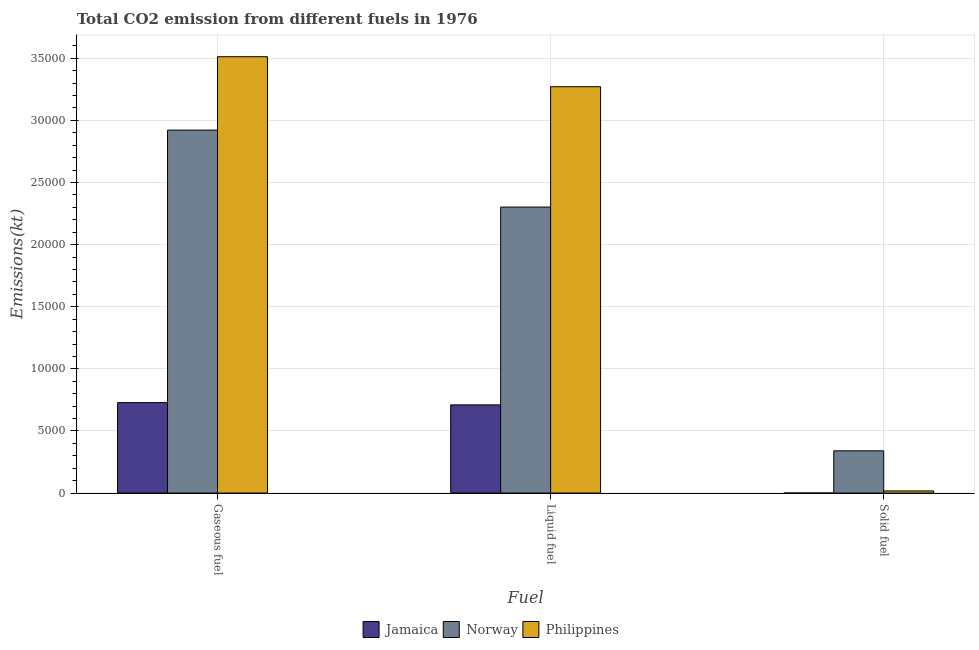How many different coloured bars are there?
Offer a very short reply. 3. How many bars are there on the 3rd tick from the left?
Give a very brief answer. 3. What is the label of the 3rd group of bars from the left?
Give a very brief answer. Solid fuel. What is the amount of co2 emissions from solid fuel in Norway?
Give a very brief answer. 3402.98. Across all countries, what is the maximum amount of co2 emissions from liquid fuel?
Your answer should be compact. 3.27e+04. Across all countries, what is the minimum amount of co2 emissions from solid fuel?
Give a very brief answer. 3.67. In which country was the amount of co2 emissions from liquid fuel maximum?
Make the answer very short. Philippines. In which country was the amount of co2 emissions from gaseous fuel minimum?
Make the answer very short. Jamaica. What is the total amount of co2 emissions from liquid fuel in the graph?
Your answer should be compact. 6.28e+04. What is the difference between the amount of co2 emissions from gaseous fuel in Philippines and that in Jamaica?
Keep it short and to the point. 2.78e+04. What is the difference between the amount of co2 emissions from solid fuel in Norway and the amount of co2 emissions from gaseous fuel in Jamaica?
Make the answer very short. -3879.69. What is the average amount of co2 emissions from liquid fuel per country?
Provide a short and direct response. 2.09e+04. What is the difference between the amount of co2 emissions from solid fuel and amount of co2 emissions from gaseous fuel in Philippines?
Your response must be concise. -3.50e+04. In how many countries, is the amount of co2 emissions from liquid fuel greater than 16000 kt?
Provide a short and direct response. 2. What is the ratio of the amount of co2 emissions from gaseous fuel in Jamaica to that in Norway?
Provide a short and direct response. 0.25. Is the amount of co2 emissions from solid fuel in Philippines less than that in Norway?
Provide a short and direct response. Yes. What is the difference between the highest and the second highest amount of co2 emissions from liquid fuel?
Your response must be concise. 9688.21. What is the difference between the highest and the lowest amount of co2 emissions from solid fuel?
Offer a terse response. 3399.31. Is the sum of the amount of co2 emissions from liquid fuel in Norway and Jamaica greater than the maximum amount of co2 emissions from solid fuel across all countries?
Your answer should be compact. Yes. What does the 3rd bar from the left in Liquid fuel represents?
Give a very brief answer. Philippines. What does the 3rd bar from the right in Liquid fuel represents?
Make the answer very short. Jamaica. Are all the bars in the graph horizontal?
Provide a succinct answer. No. How many countries are there in the graph?
Keep it short and to the point. 3. Does the graph contain any zero values?
Your answer should be compact. No. Where does the legend appear in the graph?
Make the answer very short. Bottom center. What is the title of the graph?
Offer a terse response. Total CO2 emission from different fuels in 1976. Does "Upper middle income" appear as one of the legend labels in the graph?
Provide a short and direct response. No. What is the label or title of the X-axis?
Provide a succinct answer. Fuel. What is the label or title of the Y-axis?
Ensure brevity in your answer.  Emissions(kt). What is the Emissions(kt) of Jamaica in Gaseous fuel?
Provide a short and direct response. 7282.66. What is the Emissions(kt) of Norway in Gaseous fuel?
Provide a succinct answer. 2.92e+04. What is the Emissions(kt) in Philippines in Gaseous fuel?
Offer a terse response. 3.51e+04. What is the Emissions(kt) in Jamaica in Liquid fuel?
Your response must be concise. 7099.31. What is the Emissions(kt) of Norway in Liquid fuel?
Your answer should be very brief. 2.30e+04. What is the Emissions(kt) of Philippines in Liquid fuel?
Your answer should be compact. 3.27e+04. What is the Emissions(kt) of Jamaica in Solid fuel?
Make the answer very short. 3.67. What is the Emissions(kt) of Norway in Solid fuel?
Your answer should be compact. 3402.98. What is the Emissions(kt) of Philippines in Solid fuel?
Provide a succinct answer. 172.35. Across all Fuel, what is the maximum Emissions(kt) of Jamaica?
Offer a terse response. 7282.66. Across all Fuel, what is the maximum Emissions(kt) in Norway?
Your answer should be compact. 2.92e+04. Across all Fuel, what is the maximum Emissions(kt) of Philippines?
Offer a terse response. 3.51e+04. Across all Fuel, what is the minimum Emissions(kt) in Jamaica?
Keep it short and to the point. 3.67. Across all Fuel, what is the minimum Emissions(kt) in Norway?
Provide a short and direct response. 3402.98. Across all Fuel, what is the minimum Emissions(kt) in Philippines?
Your response must be concise. 172.35. What is the total Emissions(kt) of Jamaica in the graph?
Your answer should be very brief. 1.44e+04. What is the total Emissions(kt) of Norway in the graph?
Your answer should be compact. 5.56e+04. What is the total Emissions(kt) of Philippines in the graph?
Make the answer very short. 6.80e+04. What is the difference between the Emissions(kt) of Jamaica in Gaseous fuel and that in Liquid fuel?
Your response must be concise. 183.35. What is the difference between the Emissions(kt) in Norway in Gaseous fuel and that in Liquid fuel?
Keep it short and to the point. 6193.56. What is the difference between the Emissions(kt) of Philippines in Gaseous fuel and that in Liquid fuel?
Make the answer very short. 2416.55. What is the difference between the Emissions(kt) of Jamaica in Gaseous fuel and that in Solid fuel?
Ensure brevity in your answer.  7278.99. What is the difference between the Emissions(kt) of Norway in Gaseous fuel and that in Solid fuel?
Provide a short and direct response. 2.58e+04. What is the difference between the Emissions(kt) in Philippines in Gaseous fuel and that in Solid fuel?
Your answer should be compact. 3.50e+04. What is the difference between the Emissions(kt) of Jamaica in Liquid fuel and that in Solid fuel?
Provide a succinct answer. 7095.65. What is the difference between the Emissions(kt) in Norway in Liquid fuel and that in Solid fuel?
Ensure brevity in your answer.  1.96e+04. What is the difference between the Emissions(kt) in Philippines in Liquid fuel and that in Solid fuel?
Provide a short and direct response. 3.25e+04. What is the difference between the Emissions(kt) of Jamaica in Gaseous fuel and the Emissions(kt) of Norway in Liquid fuel?
Offer a terse response. -1.57e+04. What is the difference between the Emissions(kt) of Jamaica in Gaseous fuel and the Emissions(kt) of Philippines in Liquid fuel?
Make the answer very short. -2.54e+04. What is the difference between the Emissions(kt) in Norway in Gaseous fuel and the Emissions(kt) in Philippines in Liquid fuel?
Offer a very short reply. -3494.65. What is the difference between the Emissions(kt) in Jamaica in Gaseous fuel and the Emissions(kt) in Norway in Solid fuel?
Your answer should be very brief. 3879.69. What is the difference between the Emissions(kt) of Jamaica in Gaseous fuel and the Emissions(kt) of Philippines in Solid fuel?
Your answer should be very brief. 7110.31. What is the difference between the Emissions(kt) in Norway in Gaseous fuel and the Emissions(kt) in Philippines in Solid fuel?
Your answer should be compact. 2.90e+04. What is the difference between the Emissions(kt) in Jamaica in Liquid fuel and the Emissions(kt) in Norway in Solid fuel?
Offer a terse response. 3696.34. What is the difference between the Emissions(kt) in Jamaica in Liquid fuel and the Emissions(kt) in Philippines in Solid fuel?
Ensure brevity in your answer.  6926.96. What is the difference between the Emissions(kt) in Norway in Liquid fuel and the Emissions(kt) in Philippines in Solid fuel?
Your answer should be very brief. 2.29e+04. What is the average Emissions(kt) of Jamaica per Fuel?
Keep it short and to the point. 4795.21. What is the average Emissions(kt) in Norway per Fuel?
Your response must be concise. 1.85e+04. What is the average Emissions(kt) in Philippines per Fuel?
Ensure brevity in your answer.  2.27e+04. What is the difference between the Emissions(kt) in Jamaica and Emissions(kt) in Norway in Gaseous fuel?
Provide a short and direct response. -2.19e+04. What is the difference between the Emissions(kt) of Jamaica and Emissions(kt) of Philippines in Gaseous fuel?
Offer a terse response. -2.78e+04. What is the difference between the Emissions(kt) of Norway and Emissions(kt) of Philippines in Gaseous fuel?
Ensure brevity in your answer.  -5911.2. What is the difference between the Emissions(kt) in Jamaica and Emissions(kt) in Norway in Liquid fuel?
Provide a succinct answer. -1.59e+04. What is the difference between the Emissions(kt) in Jamaica and Emissions(kt) in Philippines in Liquid fuel?
Ensure brevity in your answer.  -2.56e+04. What is the difference between the Emissions(kt) in Norway and Emissions(kt) in Philippines in Liquid fuel?
Make the answer very short. -9688.21. What is the difference between the Emissions(kt) of Jamaica and Emissions(kt) of Norway in Solid fuel?
Provide a short and direct response. -3399.31. What is the difference between the Emissions(kt) in Jamaica and Emissions(kt) in Philippines in Solid fuel?
Your response must be concise. -168.68. What is the difference between the Emissions(kt) in Norway and Emissions(kt) in Philippines in Solid fuel?
Offer a very short reply. 3230.63. What is the ratio of the Emissions(kt) of Jamaica in Gaseous fuel to that in Liquid fuel?
Make the answer very short. 1.03. What is the ratio of the Emissions(kt) of Norway in Gaseous fuel to that in Liquid fuel?
Your response must be concise. 1.27. What is the ratio of the Emissions(kt) of Philippines in Gaseous fuel to that in Liquid fuel?
Offer a terse response. 1.07. What is the ratio of the Emissions(kt) in Jamaica in Gaseous fuel to that in Solid fuel?
Provide a succinct answer. 1986. What is the ratio of the Emissions(kt) in Norway in Gaseous fuel to that in Solid fuel?
Offer a terse response. 8.59. What is the ratio of the Emissions(kt) of Philippines in Gaseous fuel to that in Solid fuel?
Give a very brief answer. 203.83. What is the ratio of the Emissions(kt) of Jamaica in Liquid fuel to that in Solid fuel?
Your answer should be compact. 1936. What is the ratio of the Emissions(kt) in Norway in Liquid fuel to that in Solid fuel?
Your response must be concise. 6.77. What is the ratio of the Emissions(kt) in Philippines in Liquid fuel to that in Solid fuel?
Keep it short and to the point. 189.81. What is the difference between the highest and the second highest Emissions(kt) of Jamaica?
Your response must be concise. 183.35. What is the difference between the highest and the second highest Emissions(kt) in Norway?
Your answer should be compact. 6193.56. What is the difference between the highest and the second highest Emissions(kt) of Philippines?
Ensure brevity in your answer.  2416.55. What is the difference between the highest and the lowest Emissions(kt) in Jamaica?
Offer a terse response. 7278.99. What is the difference between the highest and the lowest Emissions(kt) of Norway?
Your answer should be compact. 2.58e+04. What is the difference between the highest and the lowest Emissions(kt) of Philippines?
Make the answer very short. 3.50e+04. 